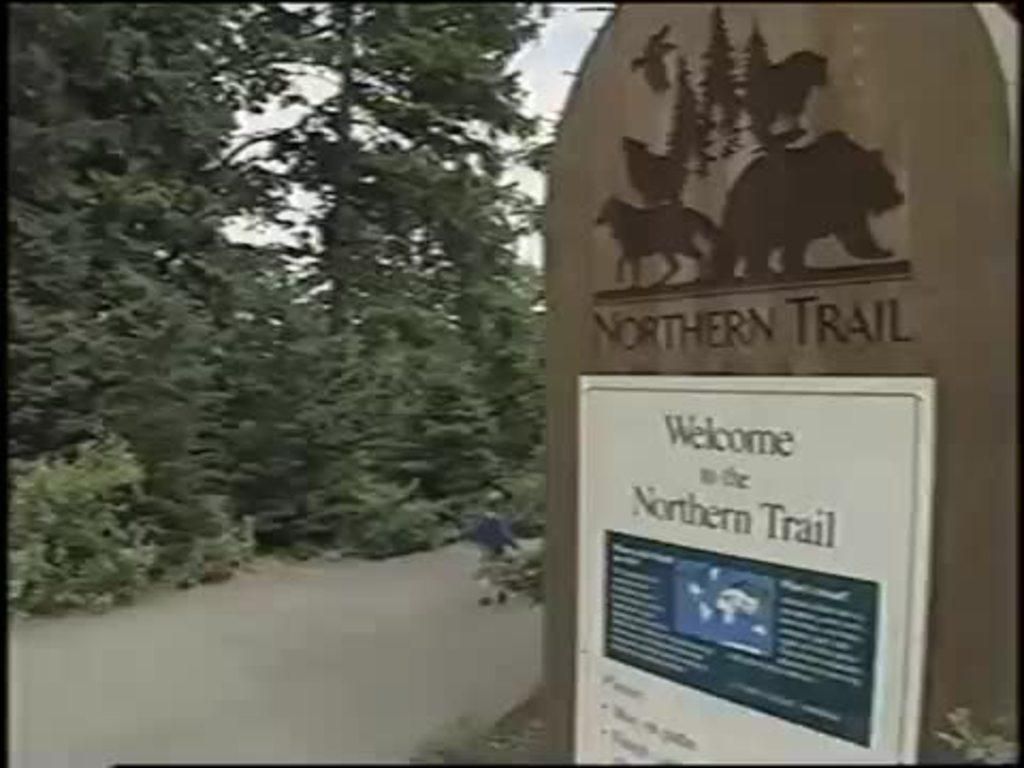<image>
Render a clear and concise summary of the photo. A pathway and a sign welcoming visitors to the Northern Trail. 